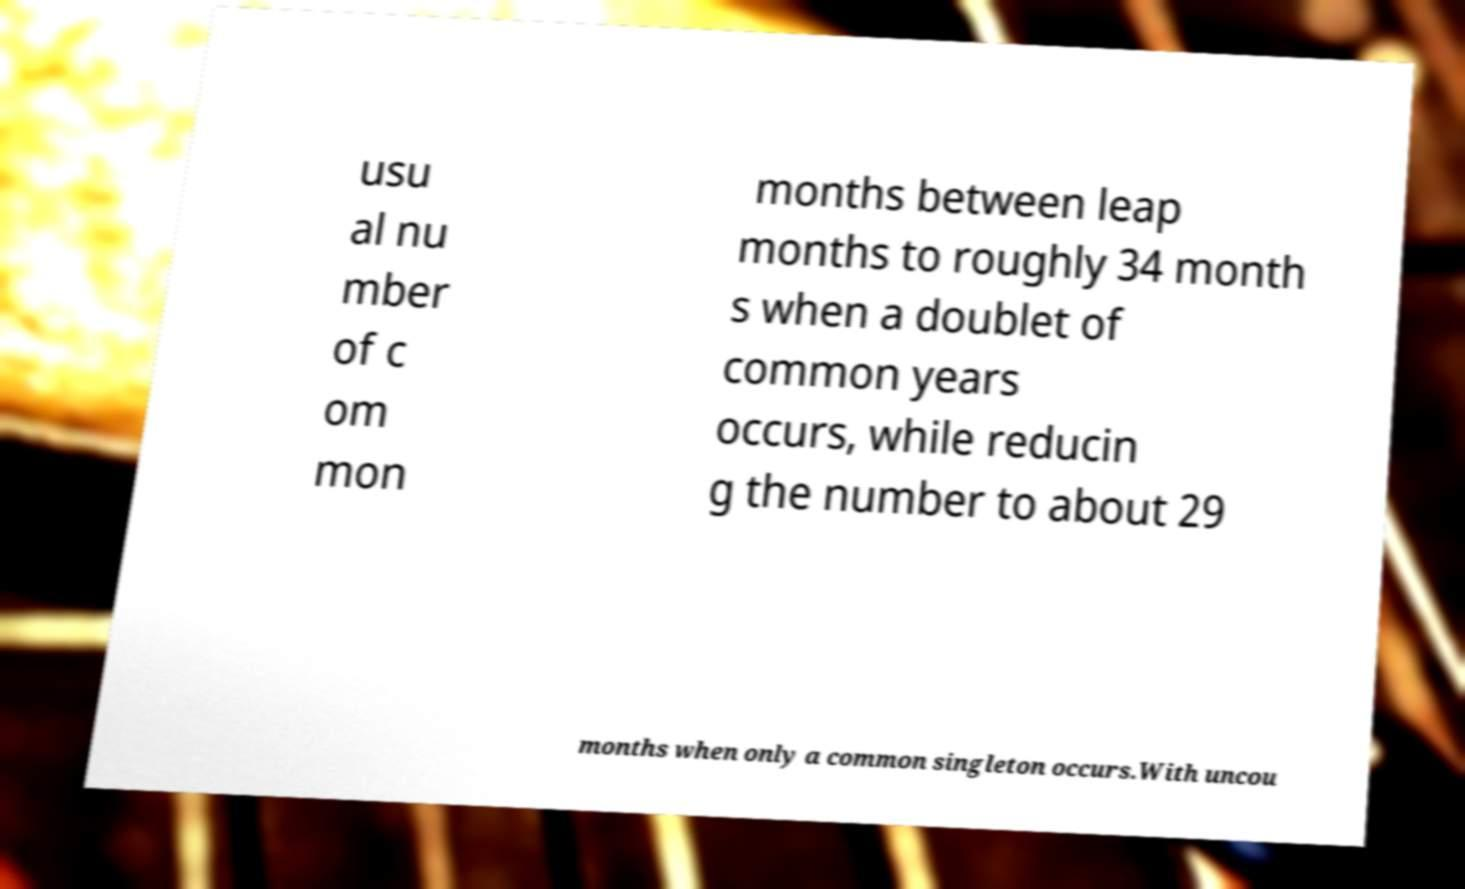Could you extract and type out the text from this image? usu al nu mber of c om mon months between leap months to roughly 34 month s when a doublet of common years occurs, while reducin g the number to about 29 months when only a common singleton occurs.With uncou 